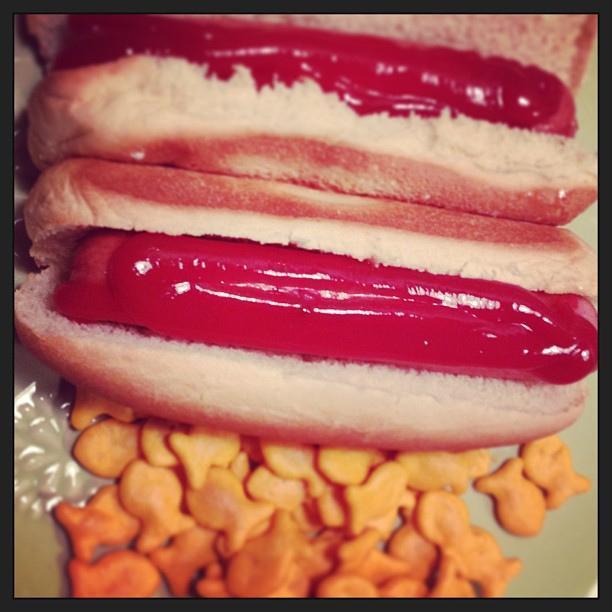How many hot dogs are there?
Give a very brief answer. 2. How many elephants are walking along the road?
Give a very brief answer. 0. 